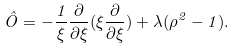<formula> <loc_0><loc_0><loc_500><loc_500>\hat { O } = - \frac { 1 } { \xi } \frac { \partial } { \partial \xi } ( \xi \frac { \partial } { \partial \xi } ) + \lambda ( \rho ^ { 2 } - 1 ) .</formula> 